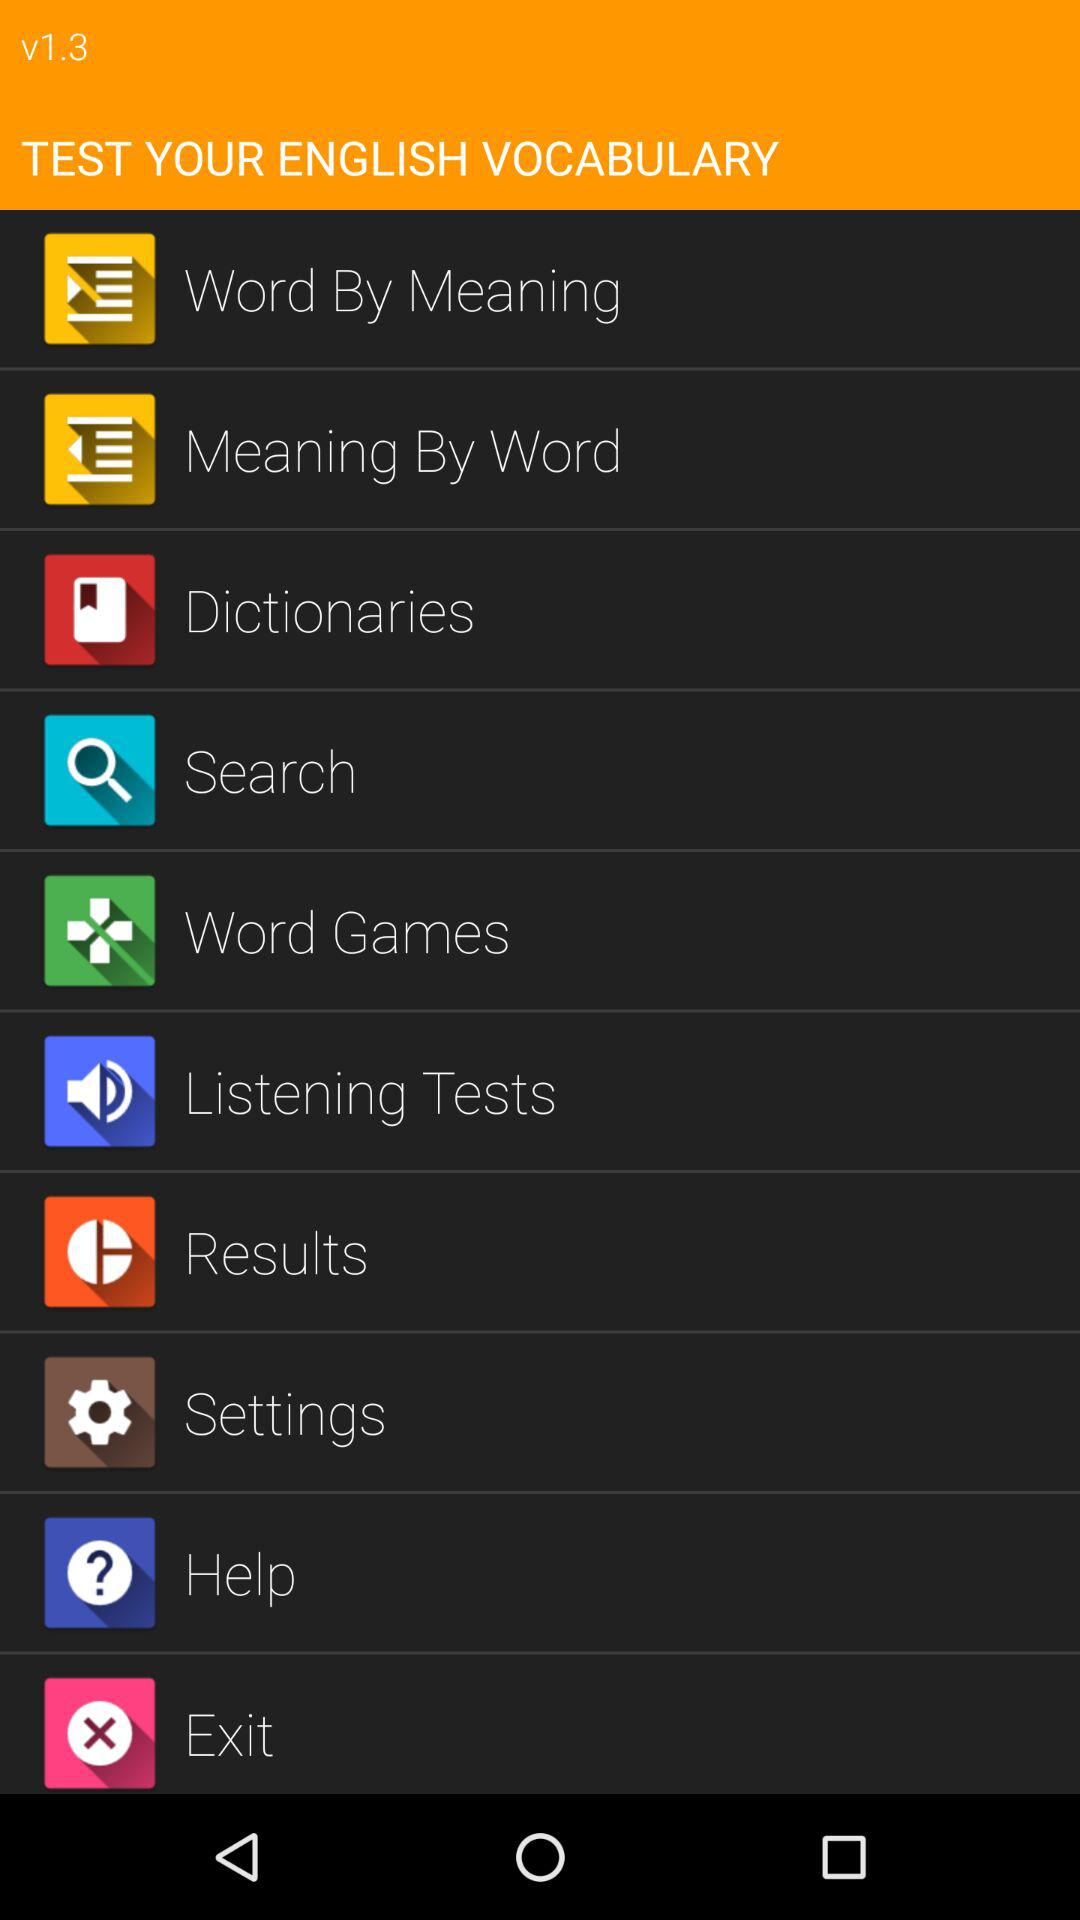What is the version of the application? The version of the application is v1.3. 